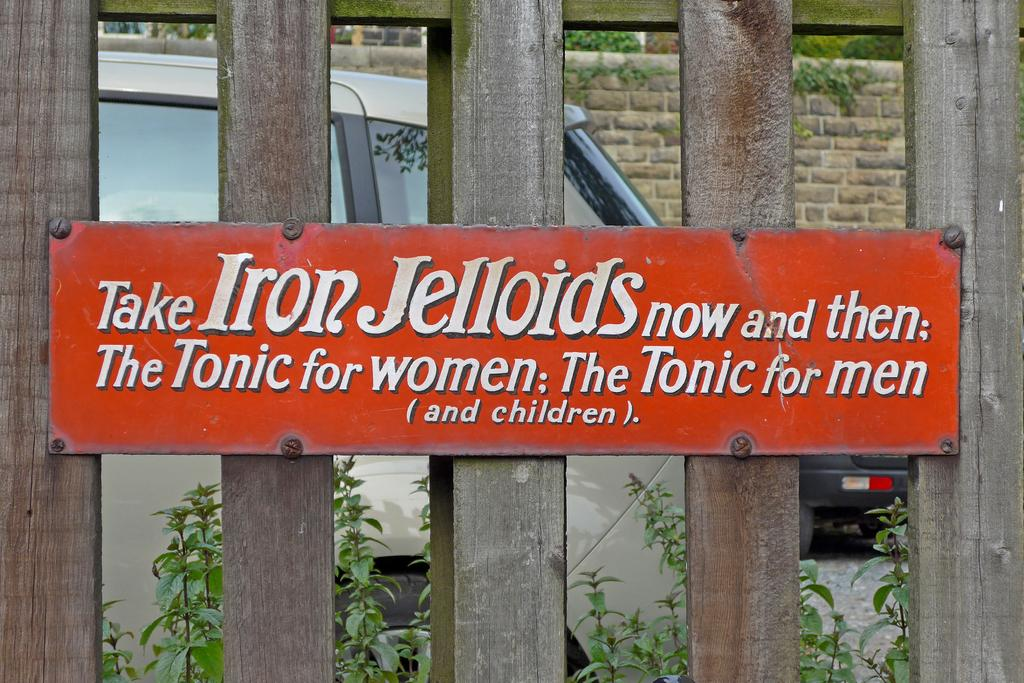What is on the wooden fence in the image? There is a red board on the wooden fence. What can be seen behind the red board? There are plants behind the red board. What type of objects are visible in the image? There are vehicles visible in the image. What is the material of the wall in the image? There is a brick wall in the image. What type of vegetation is at the back of the image? There are trees at the back of the image. How many grapes are hanging from the red board in the image? There are no grapes present in the image. Can you see a kiss between two people in the image? There is no kiss or any people visible in the image. 